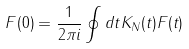<formula> <loc_0><loc_0><loc_500><loc_500>F ( 0 ) = \frac { 1 } { 2 \pi i } \oint d t K _ { N } ( t ) F ( t )</formula> 